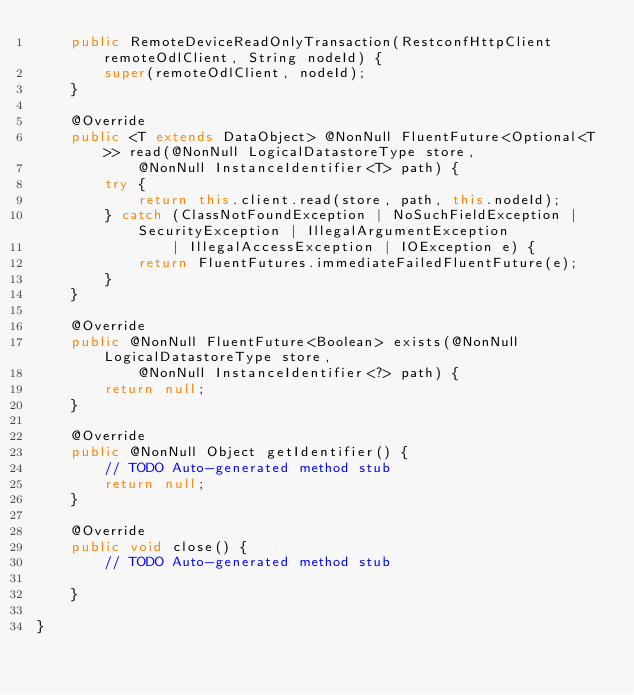Convert code to text. <code><loc_0><loc_0><loc_500><loc_500><_Java_>    public RemoteDeviceReadOnlyTransaction(RestconfHttpClient remoteOdlClient, String nodeId) {
        super(remoteOdlClient, nodeId);
    }

    @Override
    public <T extends DataObject> @NonNull FluentFuture<Optional<T>> read(@NonNull LogicalDatastoreType store,
            @NonNull InstanceIdentifier<T> path) {
        try {
            return this.client.read(store, path, this.nodeId);
        } catch (ClassNotFoundException | NoSuchFieldException | SecurityException | IllegalArgumentException
                | IllegalAccessException | IOException e) {
            return FluentFutures.immediateFailedFluentFuture(e);
        }
    }

    @Override
    public @NonNull FluentFuture<Boolean> exists(@NonNull LogicalDatastoreType store,
            @NonNull InstanceIdentifier<?> path) {
        return null;
    }

    @Override
    public @NonNull Object getIdentifier() {
        // TODO Auto-generated method stub
        return null;
    }

    @Override
    public void close() {
        // TODO Auto-generated method stub

    }

}</code> 